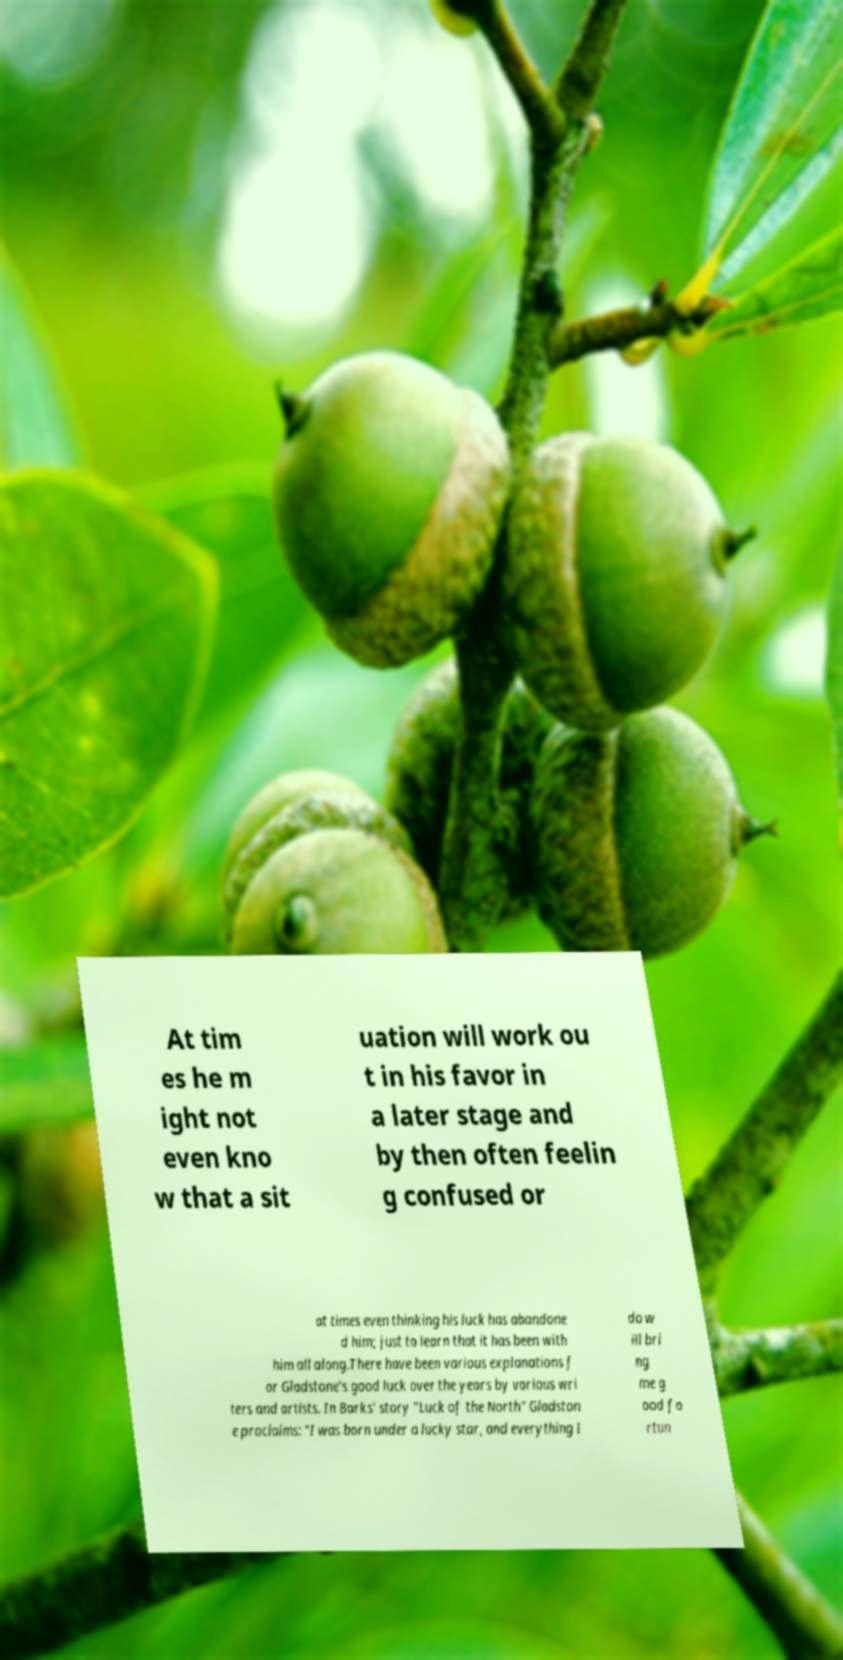Can you read and provide the text displayed in the image?This photo seems to have some interesting text. Can you extract and type it out for me? At tim es he m ight not even kno w that a sit uation will work ou t in his favor in a later stage and by then often feelin g confused or at times even thinking his luck has abandone d him; just to learn that it has been with him all along.There have been various explanations f or Gladstone's good luck over the years by various wri ters and artists. In Barks' story "Luck of the North" Gladston e proclaims: "I was born under a lucky star, and everything I do w ill bri ng me g ood fo rtun 